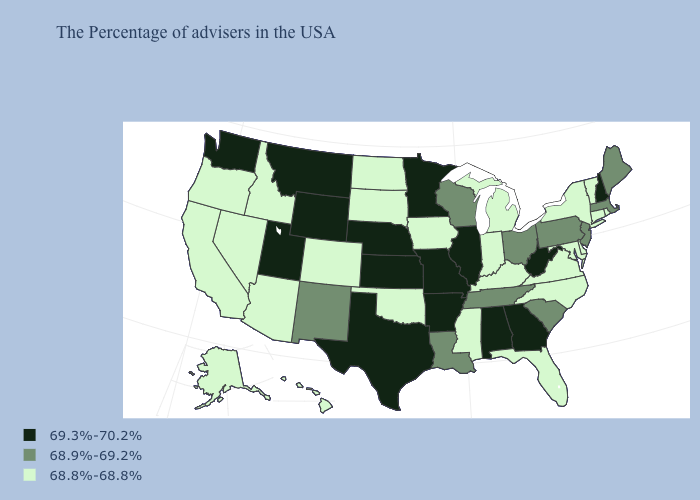What is the value of Arizona?
Be succinct. 68.8%-68.8%. What is the value of Oklahoma?
Answer briefly. 68.8%-68.8%. What is the value of Colorado?
Give a very brief answer. 68.8%-68.8%. Name the states that have a value in the range 69.3%-70.2%?
Be succinct. New Hampshire, West Virginia, Georgia, Alabama, Illinois, Missouri, Arkansas, Minnesota, Kansas, Nebraska, Texas, Wyoming, Utah, Montana, Washington. Is the legend a continuous bar?
Concise answer only. No. Name the states that have a value in the range 68.8%-68.8%?
Short answer required. Rhode Island, Vermont, Connecticut, New York, Delaware, Maryland, Virginia, North Carolina, Florida, Michigan, Kentucky, Indiana, Mississippi, Iowa, Oklahoma, South Dakota, North Dakota, Colorado, Arizona, Idaho, Nevada, California, Oregon, Alaska, Hawaii. Does Arizona have a lower value than Colorado?
Concise answer only. No. Does the first symbol in the legend represent the smallest category?
Concise answer only. No. Does Hawaii have a higher value than Mississippi?
Concise answer only. No. Does Georgia have the lowest value in the USA?
Write a very short answer. No. What is the value of Minnesota?
Short answer required. 69.3%-70.2%. Name the states that have a value in the range 68.8%-68.8%?
Quick response, please. Rhode Island, Vermont, Connecticut, New York, Delaware, Maryland, Virginia, North Carolina, Florida, Michigan, Kentucky, Indiana, Mississippi, Iowa, Oklahoma, South Dakota, North Dakota, Colorado, Arizona, Idaho, Nevada, California, Oregon, Alaska, Hawaii. What is the lowest value in states that border North Dakota?
Short answer required. 68.8%-68.8%. What is the highest value in the South ?
Short answer required. 69.3%-70.2%. Which states hav the highest value in the West?
Give a very brief answer. Wyoming, Utah, Montana, Washington. 